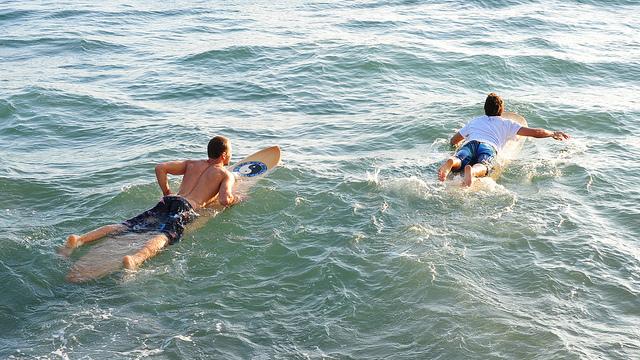How many people are in the water?
Keep it brief. 2. How does the child keep from losing his board?
Give a very brief answer. Staying on it. Do you see a big wave coming?
Write a very short answer. No. What are the people riding on?
Short answer required. Surfboards. 